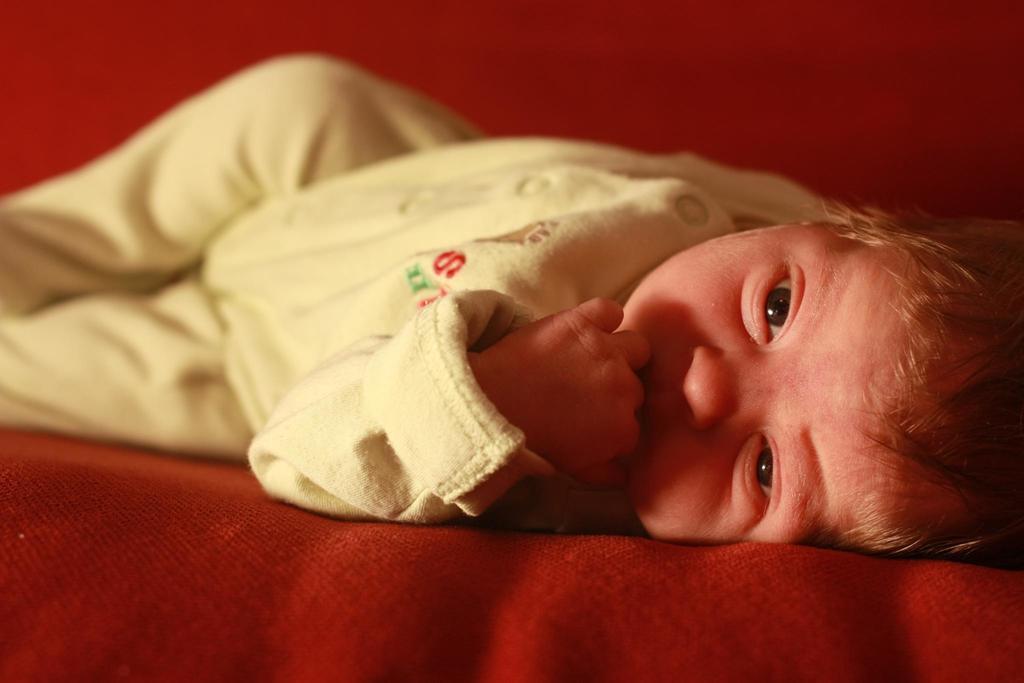How would you summarize this image in a sentence or two? In this picture I can observe a baby laying on the bed. The baby is wearing cream color dress. 